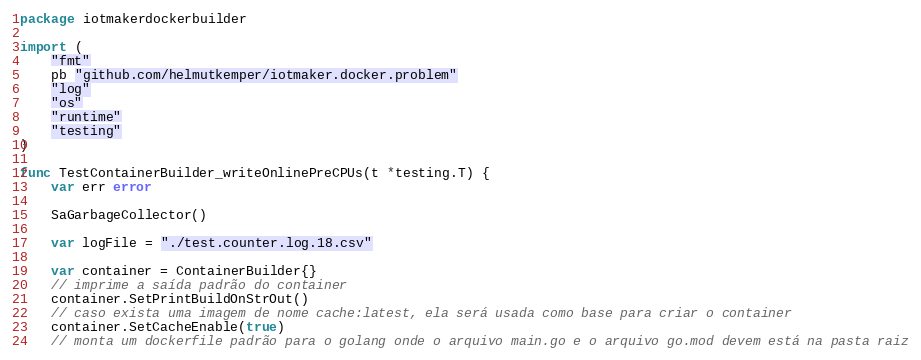<code> <loc_0><loc_0><loc_500><loc_500><_Go_>package iotmakerdockerbuilder

import (
	"fmt"
	pb "github.com/helmutkemper/iotmaker.docker.problem"
	"log"
	"os"
	"runtime"
	"testing"
)

func TestContainerBuilder_writeOnlinePreCPUs(t *testing.T) {
	var err error

	SaGarbageCollector()

	var logFile = "./test.counter.log.18.csv"

	var container = ContainerBuilder{}
	// imprime a saída padrão do container
	container.SetPrintBuildOnStrOut()
	// caso exista uma imagem de nome cache:latest, ela será usada como base para criar o container
	container.SetCacheEnable(true)
	// monta um dockerfile padrão para o golang onde o arquivo main.go e o arquivo go.mod devem está na pasta raiz</code> 